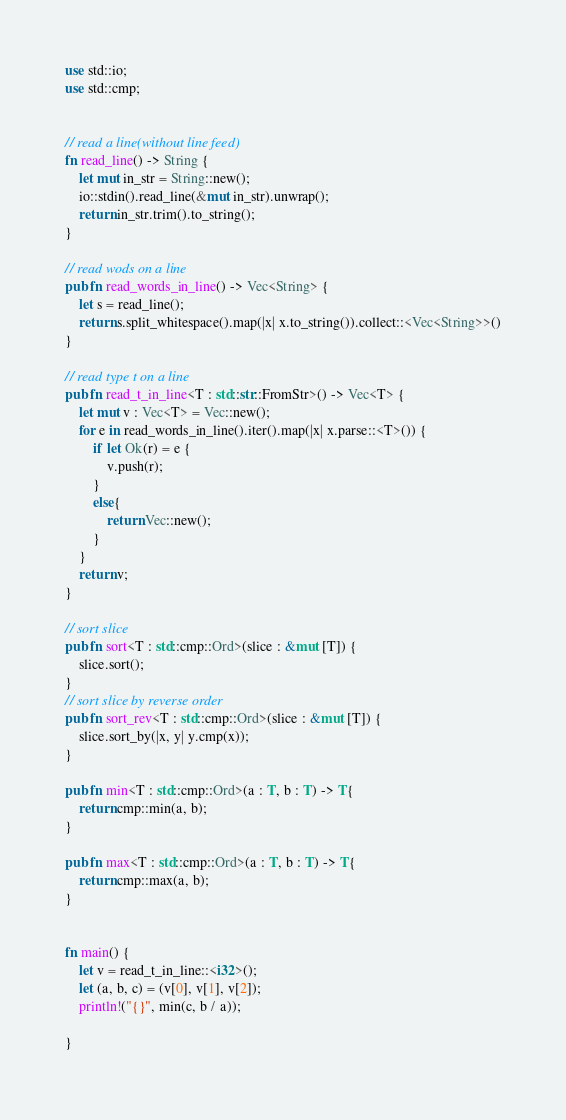<code> <loc_0><loc_0><loc_500><loc_500><_Rust_>use std::io;
use std::cmp;


// read a line(without line feed)
fn read_line() -> String {
    let mut in_str = String::new();
    io::stdin().read_line(&mut in_str).unwrap();
    return in_str.trim().to_string();
}

// read wods on a line
pub fn read_words_in_line() -> Vec<String> {
    let s = read_line();
    return s.split_whitespace().map(|x| x.to_string()).collect::<Vec<String>>()
}

// read type t on a line
pub fn read_t_in_line<T : std::str::FromStr>() -> Vec<T> {
    let mut v : Vec<T> = Vec::new();
    for e in read_words_in_line().iter().map(|x| x.parse::<T>()) {
        if let Ok(r) = e {
            v.push(r);
        }
        else{
            return Vec::new();
        }
    }
    return v;
}

// sort slice
pub fn sort<T : std::cmp::Ord>(slice : &mut [T]) {
    slice.sort();
}
// sort slice by reverse order
pub fn sort_rev<T : std::cmp::Ord>(slice : &mut [T]) {
    slice.sort_by(|x, y| y.cmp(x));
}

pub fn min<T : std::cmp::Ord>(a : T, b : T) -> T{
    return cmp::min(a, b);
}

pub fn max<T : std::cmp::Ord>(a : T, b : T) -> T{
    return cmp::max(a, b);
}


fn main() {
    let v = read_t_in_line::<i32>();
    let (a, b, c) = (v[0], v[1], v[2]);
    println!("{}", min(c, b / a));

}
</code> 